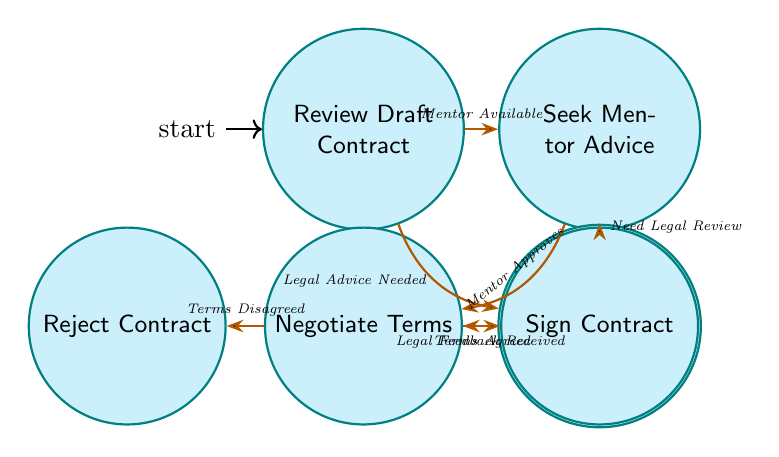What is the initial state in the diagram? The diagram starts with the state labeled "Review Draft Contract," which is indicated as the initial state by the arrow pointing towards it.
Answer: Review Draft Contract How many nodes are present in the diagram? The nodes in the diagram correspond to each of the key steps in the process. Counting each distinct state (including "Review Draft Contract," "Seek Mentor Advice," "Consult Entertainment Lawyer," "Negotiate Terms," "Sign Contract," and "Reject Contract"), there are a total of six nodes.
Answer: 6 What event leads from "Review Draft Contract" to "Seek Mentor Advice"? The event that transitions from "Review Draft Contract" to "Seek Mentor Advice" is labeled "Mentor Available." This event is depicted on the edge connecting the two states.
Answer: Mentor Available Which state do you reach after "Consult Entertainment Lawyer" if you receive legal feedback? After receiving legal feedback, the next state is "Negotiate Terms." The transition from "Consult Entertainment Lawyer" to "Negotiate Terms" is triggered by the event "Legal Feedback Received."
Answer: Negotiate Terms What are the two possible outcomes after "Negotiate Terms"? After "Negotiate Terms," the two possible outcomes are either signing the contract or rejecting it based on whether the terms are agreed upon or disagreed upon. This can be traced by the edges leading to "Sign Contract" and "Reject Contract."
Answer: Sign Contract, Reject Contract What must happen to move from "Seek Mentor Advice" to "Negotiate Terms"? To transition from "Seek Mentor Advice" to "Negotiate Terms," the event that must occur is "Mentor Approves." This is depicted along the edge leading from "Seek Mentor Advice" to "Negotiate Terms."
Answer: Mentor Approves How does one proceed to consult an entertainment lawyer directly from "Review Draft Contract"? The transition to consult an entertainment lawyer directly from "Review Draft Contract" requires the event "Legal Advice Needed." This is shown on the edge between these two states in the diagram.
Answer: Legal Advice Needed Which state signifies the completion of the contract process? The state that signifies the completion of the contract process is "Sign Contract." This is the final state representing that all terms have been agreed upon and the contract is executed.
Answer: Sign Contract What event leads from "Negotiate Terms" to "Reject Contract"? The event that leads from "Negotiate Terms" to "Reject Contract" is labeled "Terms Disagreed." This is indicated on the edge connecting these two states in the diagram.
Answer: Terms Disagreed 